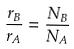Convert formula to latex. <formula><loc_0><loc_0><loc_500><loc_500>\frac { r _ { B } } { r _ { A } } = \frac { N _ { B } } { N _ { A } }</formula> 